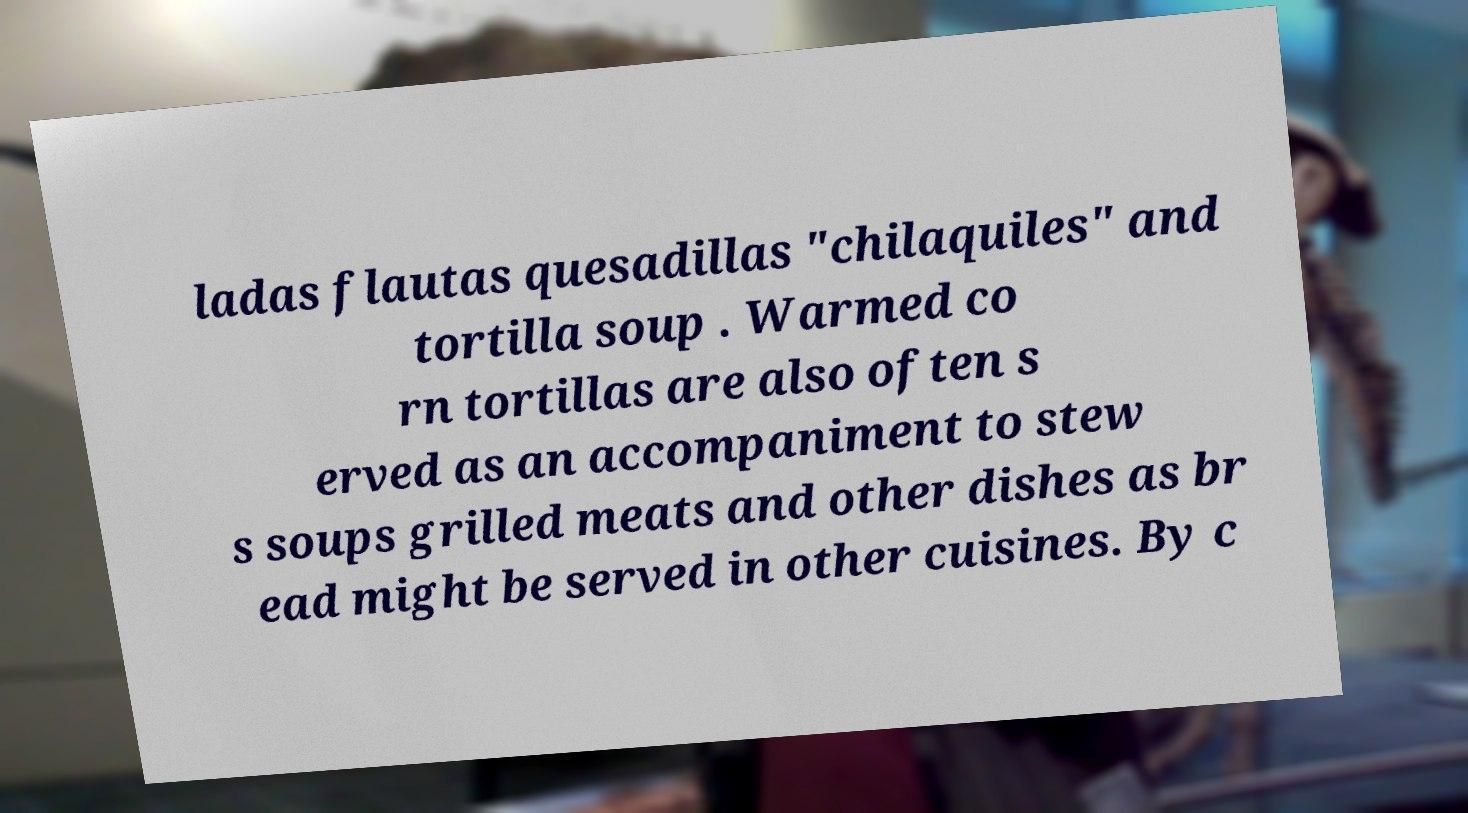Could you extract and type out the text from this image? ladas flautas quesadillas "chilaquiles" and tortilla soup . Warmed co rn tortillas are also often s erved as an accompaniment to stew s soups grilled meats and other dishes as br ead might be served in other cuisines. By c 